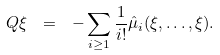Convert formula to latex. <formula><loc_0><loc_0><loc_500><loc_500>Q \xi \ = \ - \sum _ { i \geq 1 } \frac { 1 } { i ! } \hat { \mu } _ { i } ( \xi , \dots , \xi ) .</formula> 